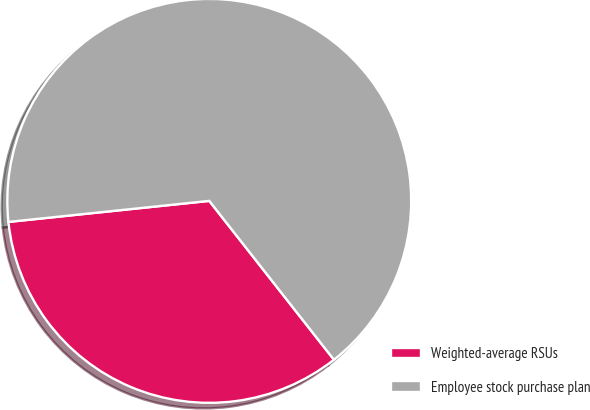Convert chart to OTSL. <chart><loc_0><loc_0><loc_500><loc_500><pie_chart><fcel>Weighted-average RSUs<fcel>Employee stock purchase plan<nl><fcel>33.93%<fcel>66.07%<nl></chart> 